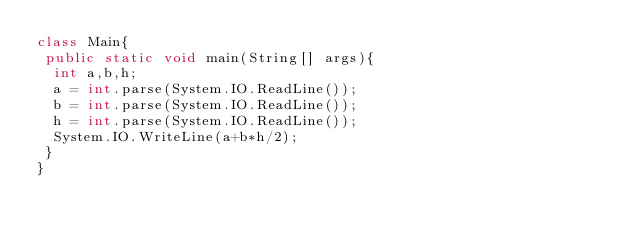Convert code to text. <code><loc_0><loc_0><loc_500><loc_500><_C#_>class Main{
 public static void main(String[] args){
  int a,b,h;
  a = int.parse(System.IO.ReadLine());
  b = int.parse(System.IO.ReadLine());
  h = int.parse(System.IO.ReadLine());
  System.IO.WriteLine(a+b*h/2);
 }
}</code> 